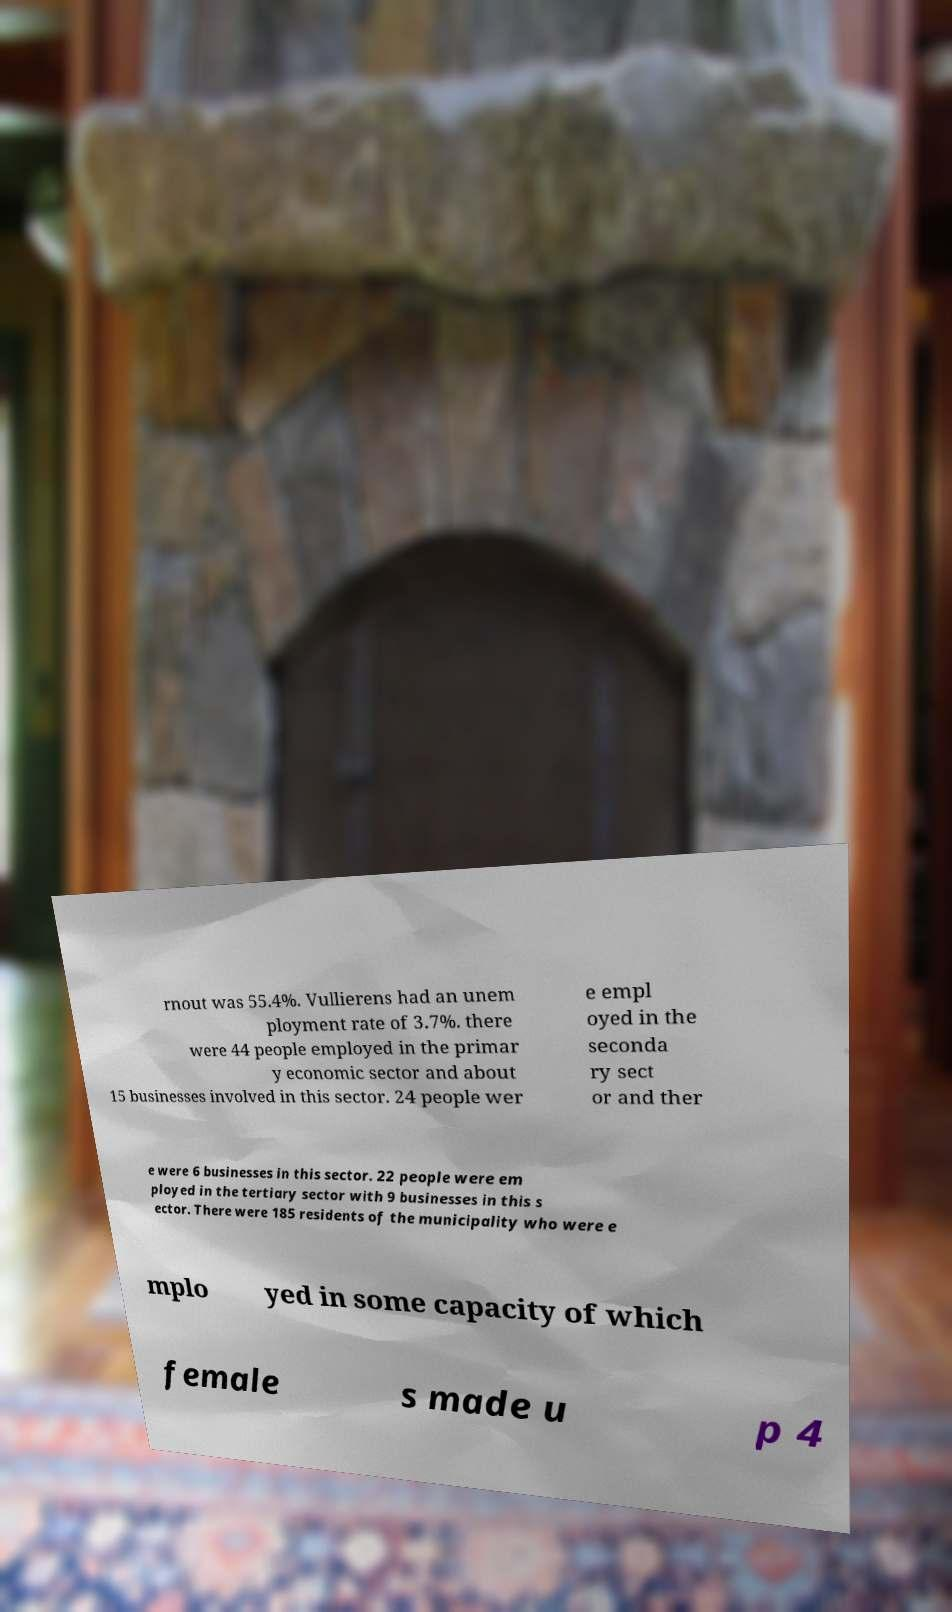What messages or text are displayed in this image? I need them in a readable, typed format. rnout was 55.4%. Vullierens had an unem ployment rate of 3.7%. there were 44 people employed in the primar y economic sector and about 15 businesses involved in this sector. 24 people wer e empl oyed in the seconda ry sect or and ther e were 6 businesses in this sector. 22 people were em ployed in the tertiary sector with 9 businesses in this s ector. There were 185 residents of the municipality who were e mplo yed in some capacity of which female s made u p 4 